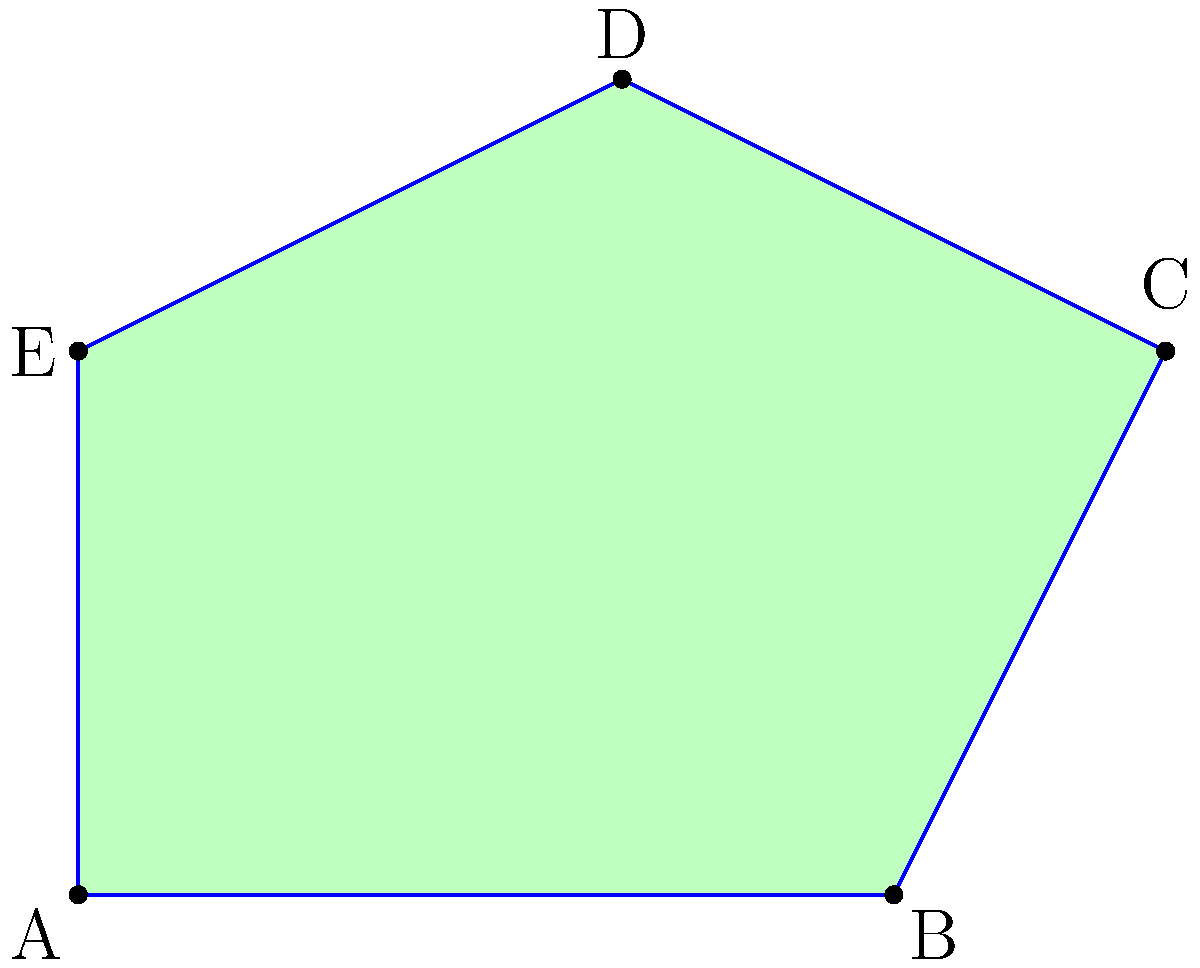A new commemorative Swiss stamp is being designed in the shape of an irregular pentagon, inspired by Hans Erni's artistic style. The stamp's shape is shown in the diagram above. What is the sum of all interior angles of this pentagonal stamp? To find the sum of all interior angles of the pentagonal stamp, we can follow these steps:

1. Recall the formula for the sum of interior angles of a polygon:
   $$(n - 2) \times 180^\circ$$
   where $n$ is the number of sides in the polygon.

2. In this case, we have a pentagon, so $n = 5$.

3. Let's substitute this into our formula:
   $$(5 - 2) \times 180^\circ$$

4. Simplify:
   $$3 \times 180^\circ = 540^\circ$$

Therefore, regardless of the specific angles or irregularity of the pentagon shape, the sum of all interior angles will always be 540°.

This principle applies to all pentagons, including the uniquely shaped Swiss stamp inspired by Hans Erni's artistic style.
Answer: $540^\circ$ 